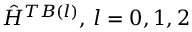Convert formula to latex. <formula><loc_0><loc_0><loc_500><loc_500>\hat { H } ^ { T B ( l ) } , \, l = 0 , 1 , 2</formula> 